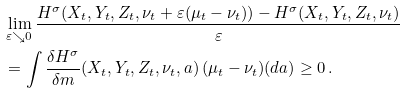<formula> <loc_0><loc_0><loc_500><loc_500>& \lim _ { \varepsilon \searrow 0 } \frac { H ^ { \sigma } ( X _ { t } , Y _ { t } , Z _ { t } , \nu _ { t } + \varepsilon ( \mu _ { t } - \nu _ { t } ) ) - H ^ { \sigma } ( X _ { t } , Y _ { t } , Z _ { t } , \nu _ { t } ) } { \varepsilon } \\ & = \int \frac { \delta H ^ { \sigma } } { \delta m } ( X _ { t } , Y _ { t } , Z _ { t } , \nu _ { t } , a ) \, ( \mu _ { t } - \nu _ { t } ) ( d a ) \geq 0 \, .</formula> 